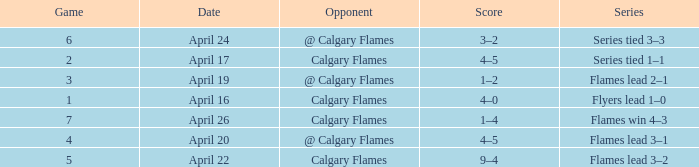Which Date has a Game smaller than 4, and an Opponent of calgary flames, and a Score of 4–5? April 17. 